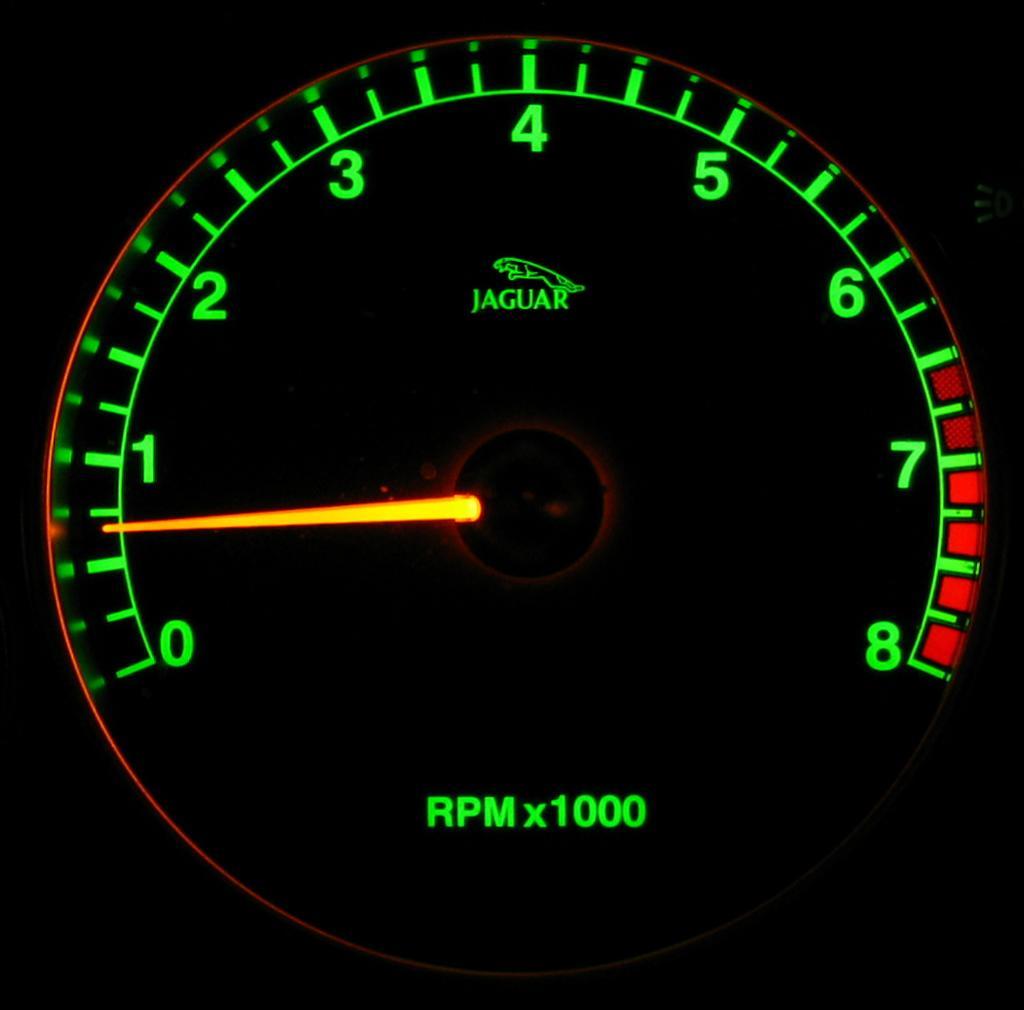Please provide a concise description of this image. In this picture we can see a close view of the rpm meter of the Jaguar car. 